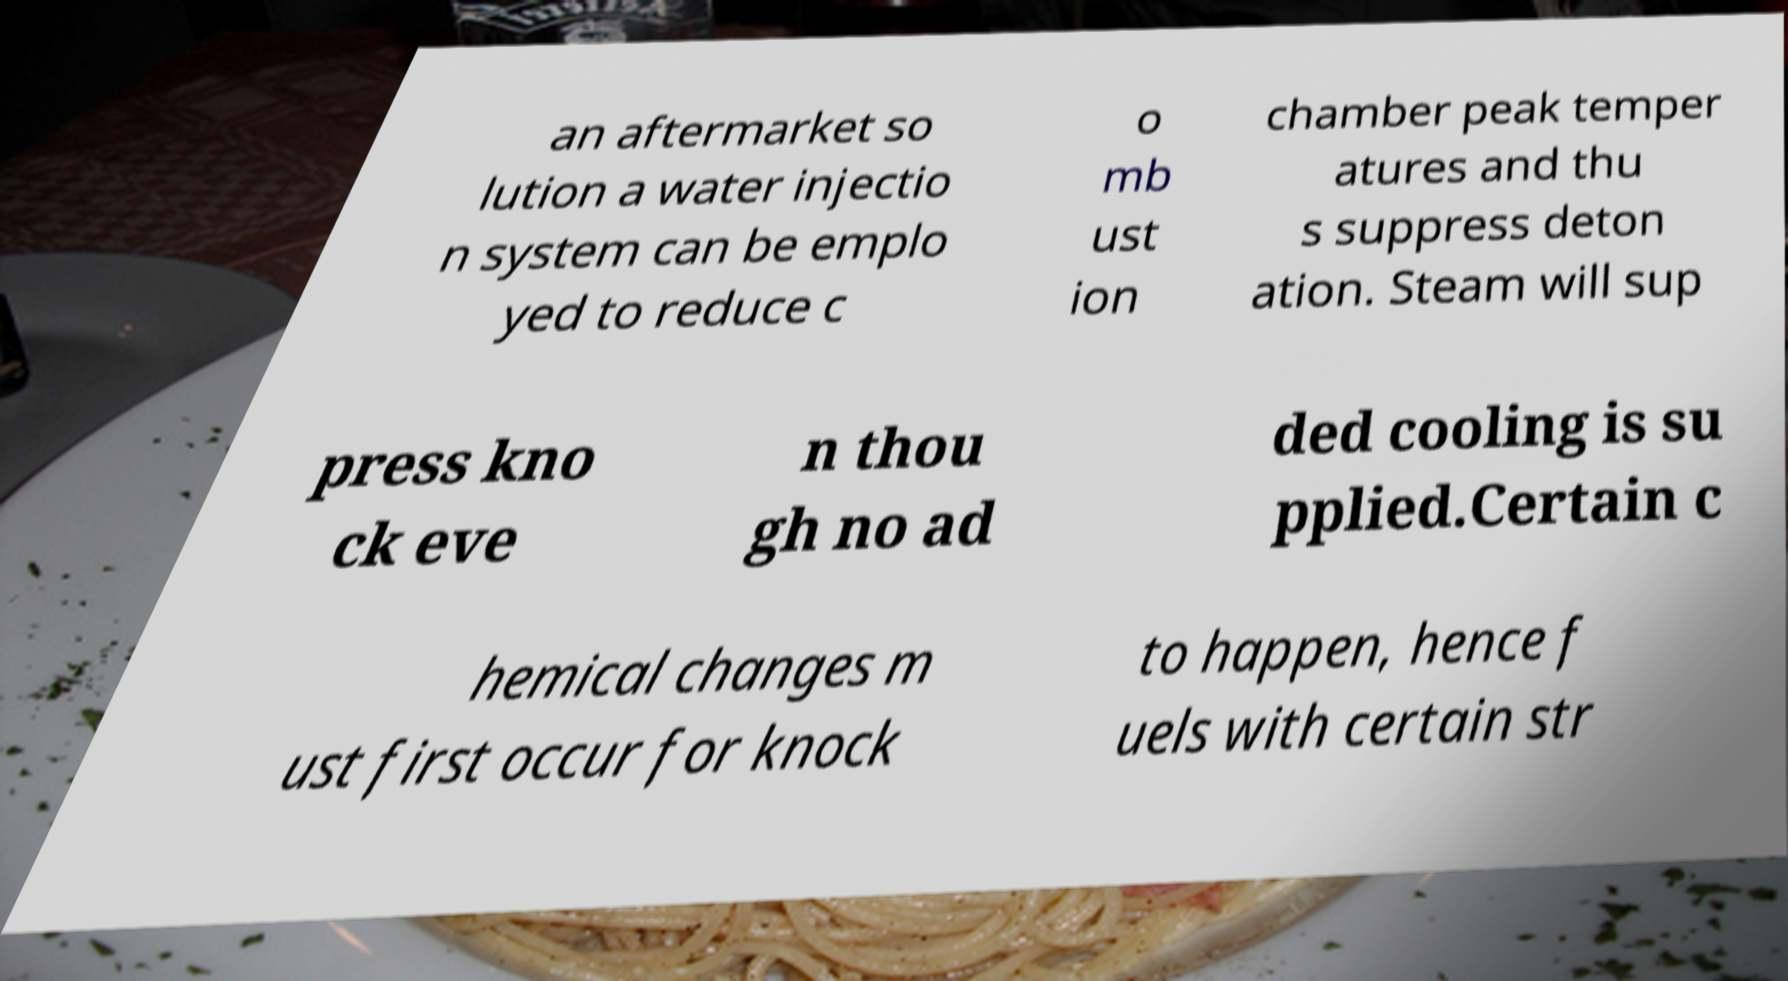Could you assist in decoding the text presented in this image and type it out clearly? an aftermarket so lution a water injectio n system can be emplo yed to reduce c o mb ust ion chamber peak temper atures and thu s suppress deton ation. Steam will sup press kno ck eve n thou gh no ad ded cooling is su pplied.Certain c hemical changes m ust first occur for knock to happen, hence f uels with certain str 